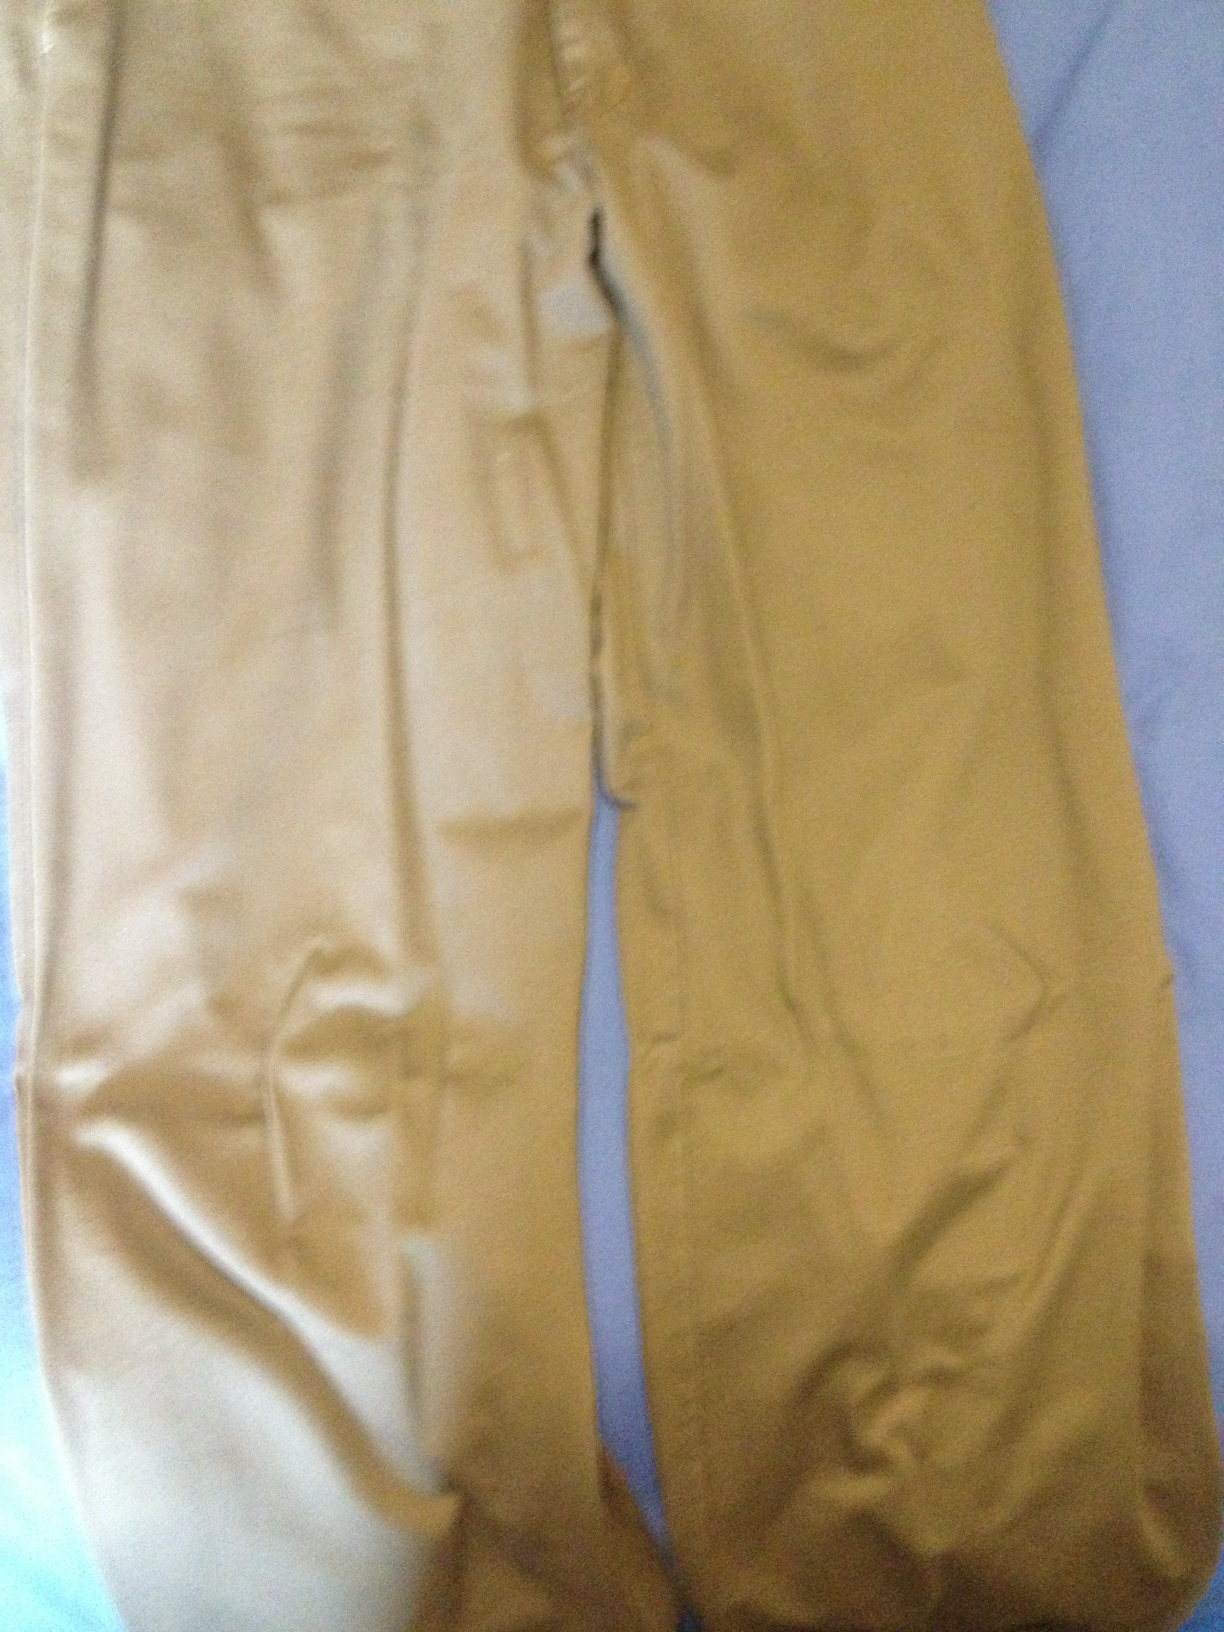Could you tell me what color these trousers are, please. from Vizwiz tan 